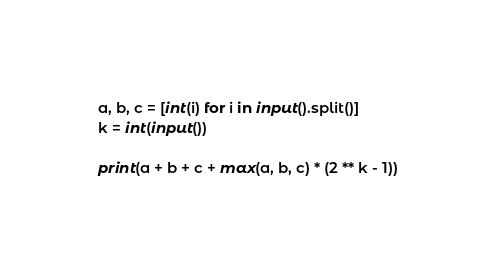<code> <loc_0><loc_0><loc_500><loc_500><_Python_>a, b, c = [int(i) for i in input().split()]
k = int(input())

print(a + b + c + max(a, b, c) * (2 ** k - 1))</code> 